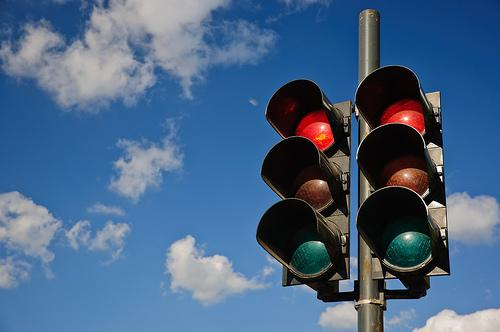Describe the appearance of the pole holding the traffic lights. The pole holding the traffic lights is large, grey, and has some rust spots on the top and the bottom. Mention the type and color of the lights that are turned on. The lights that are turned on are red, and they are stop lights. How many lanes do the traffic lights in the image appear to be for? The traffic lights appear to be for two lanes. Identify the main colors present in the sky of the image. The sky is dominated by light blue and white, as it is a cloudy, blue sky day. Describe the current weather and sky conditions in the image. The weather appears to be clear and the sky is cloudy with light blue tones. Evaluate if the traffic lights are working properly and explain your reasoning. The traffic lights seem to be functioning properly as the red lights are lit, indicating to stop, while the yellow and green lights remain off. Provide a brief description of the stop lights in the image including their color and status. There are two sets of traffic lights with red, yellow, and green colors. The red lights are lit, while the yellow and green lights are turned off. What is holding the traffic lights and what color is it? A tall, black, metal pole is holding the traffic lights. What is the overall scene of the image? The scene depicts a daytime, outdoor setting with a cloudy blue sky, and double traffic stoplights supported by a metal pole. Which particular lights are switched on in the image? The two red lights of the traffic lights are switched on. 